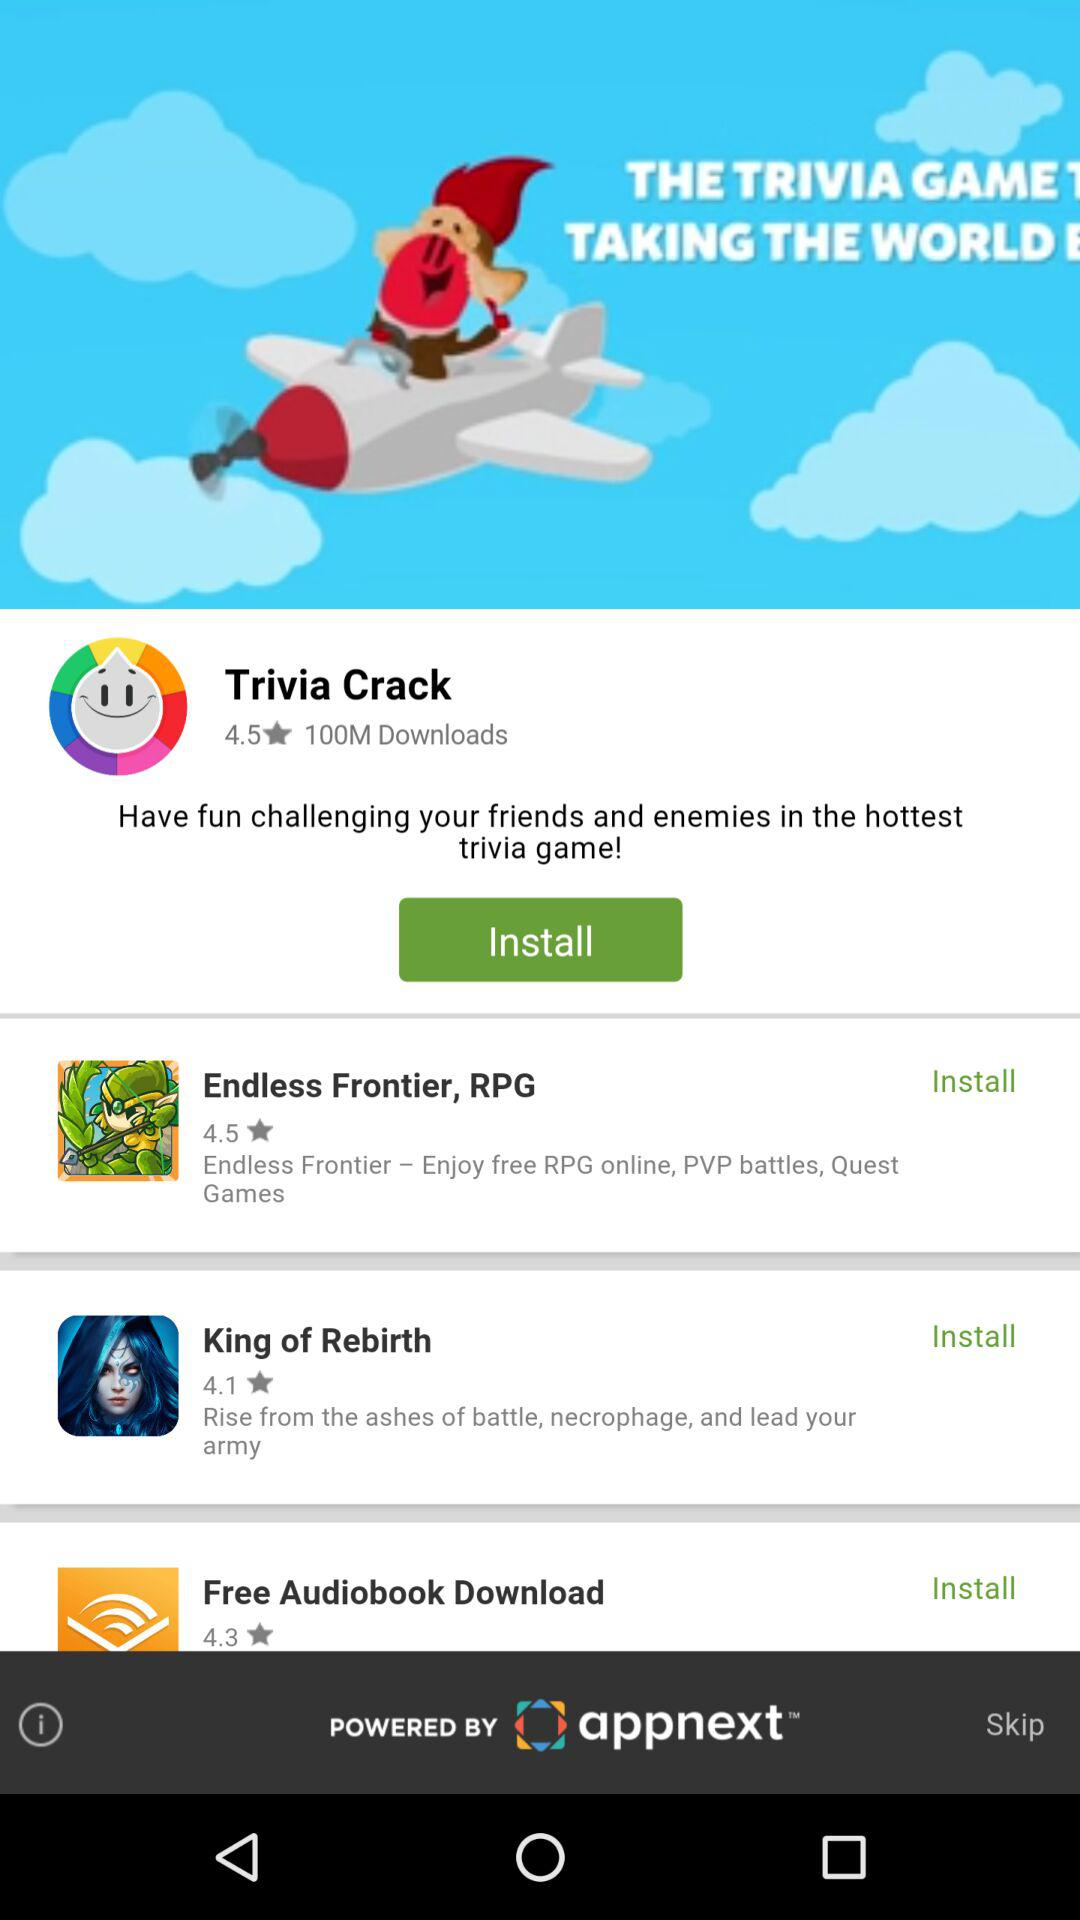How many more apps have a rating of 4.5 or higher than apps that have a rating of 4.0 or lower?
Answer the question using a single word or phrase. 2 